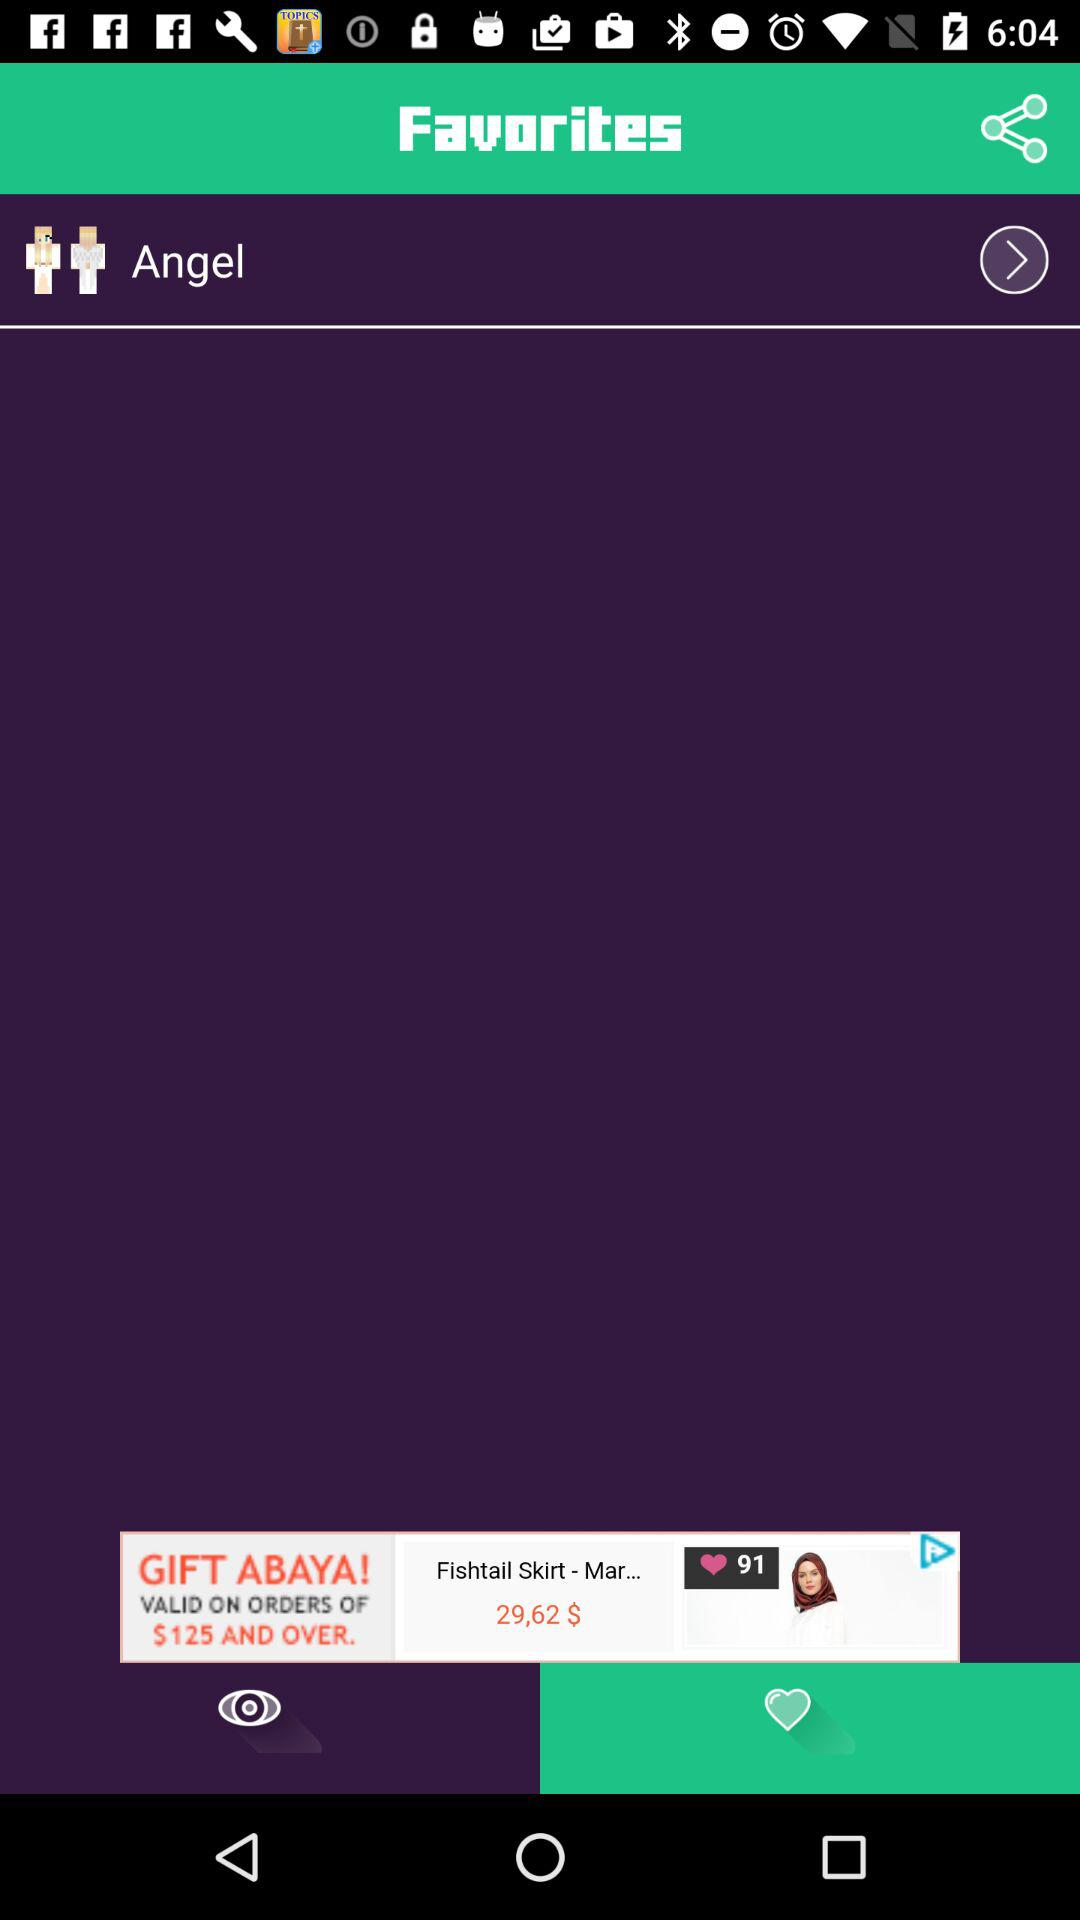What is the application name? The application name is "Favorites". 